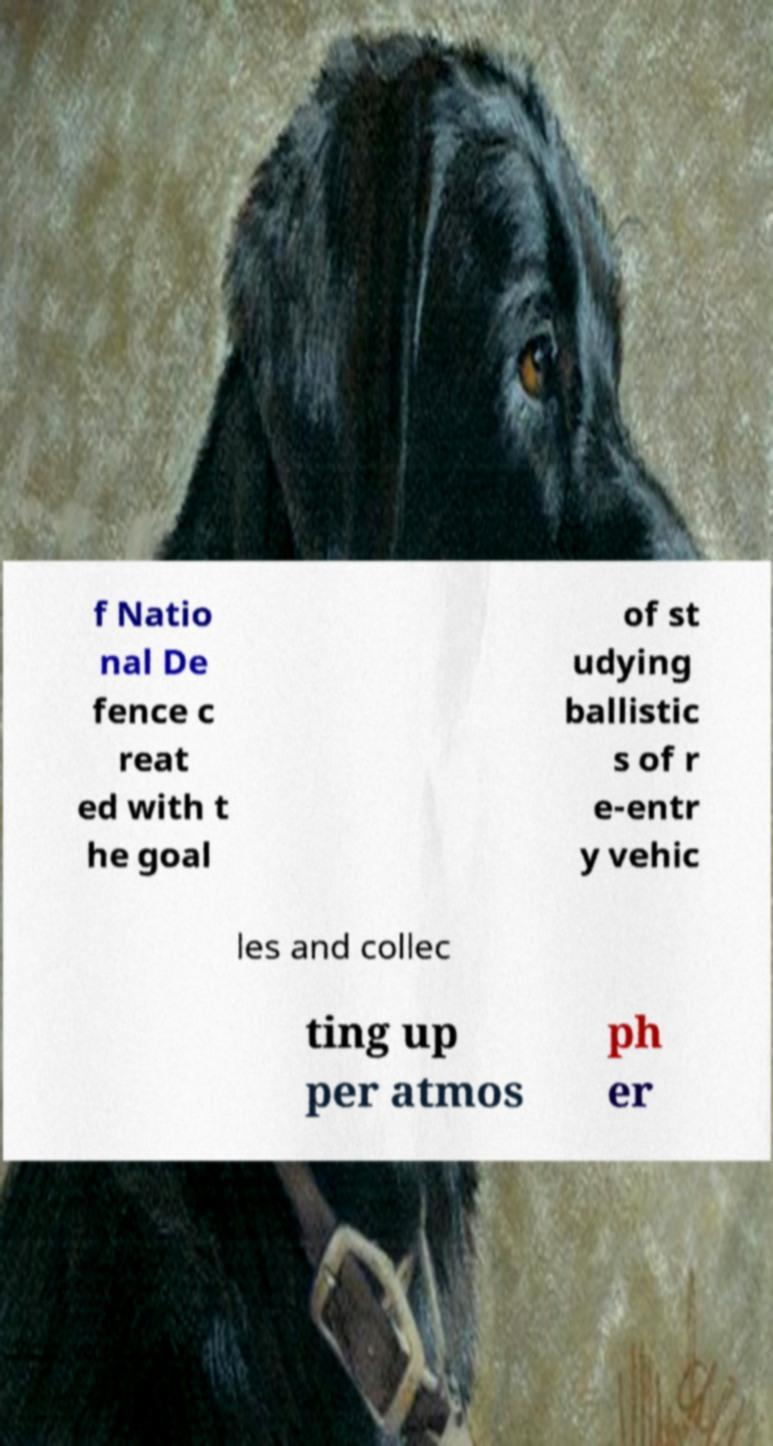For documentation purposes, I need the text within this image transcribed. Could you provide that? f Natio nal De fence c reat ed with t he goal of st udying ballistic s of r e-entr y vehic les and collec ting up per atmos ph er 